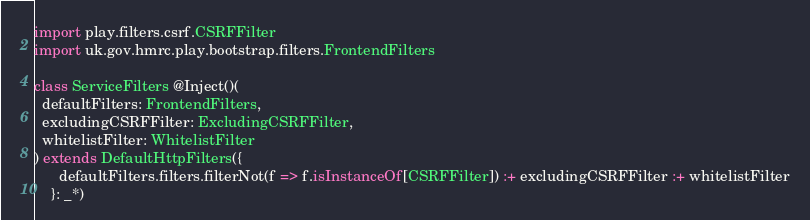<code> <loc_0><loc_0><loc_500><loc_500><_Scala_>import play.filters.csrf.CSRFFilter
import uk.gov.hmrc.play.bootstrap.filters.FrontendFilters

class ServiceFilters @Inject()(
  defaultFilters: FrontendFilters,
  excludingCSRFFilter: ExcludingCSRFFilter,
  whitelistFilter: WhitelistFilter
) extends DefaultHttpFilters({
      defaultFilters.filters.filterNot(f => f.isInstanceOf[CSRFFilter]) :+ excludingCSRFFilter :+ whitelistFilter
    }: _*)
</code> 